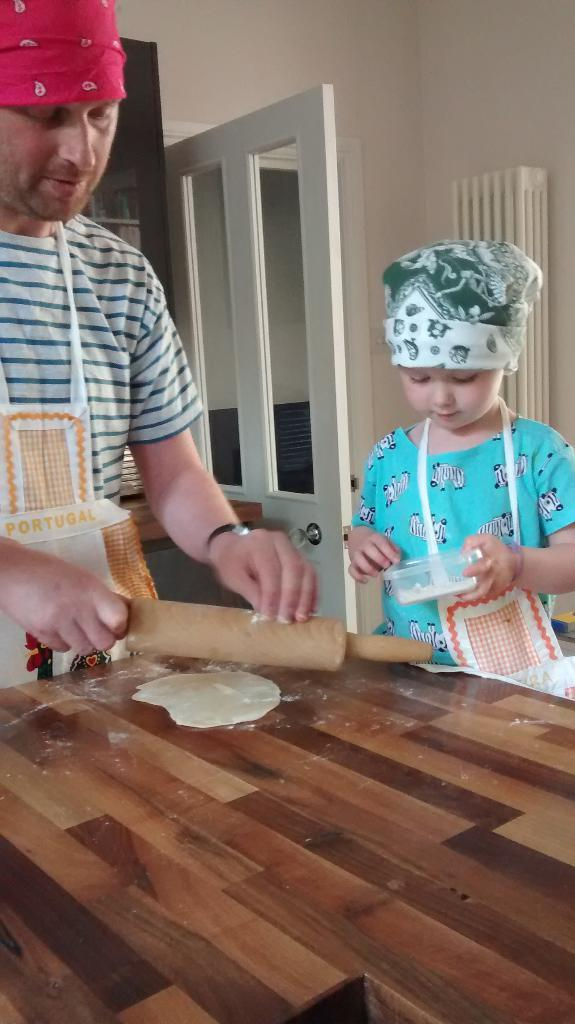Who is present in the image? There is a man and a kid in the image. What are the man and the kid wearing? Both the man and the kid are wearing aprons and caps. What is the man holding in the image? The man is holding a roll. What can be seen on the table in the image? There is food on the table. What is the kid holding in the image? The kid is holding a container. What architectural feature is visible in the image? There is a door with a handle in the image. Can you see any passengers in the image? There are no passengers present in the image; it features a man and a kid wearing aprons and caps. Is there any magic happening in the image? There is no indication of magic in the image; it shows a man and a kid engaged in a non-magical activity. 